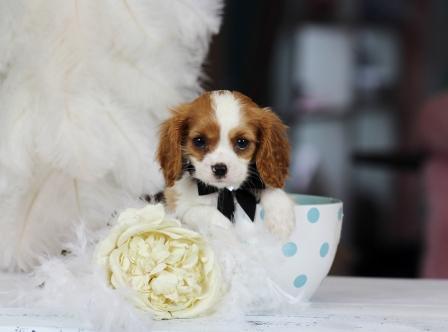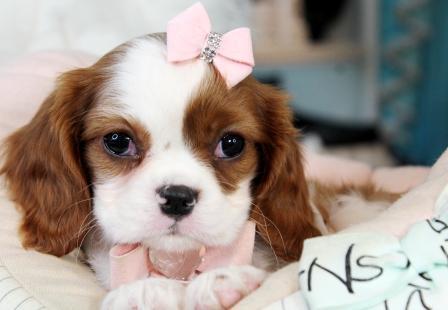The first image is the image on the left, the second image is the image on the right. For the images shown, is this caption "A person is holding up two dogs in the image on the left." true? Answer yes or no. No. The first image is the image on the left, the second image is the image on the right. Assess this claim about the two images: "The right image shows a small brown and white dog with a bow on its head". Correct or not? Answer yes or no. Yes. 